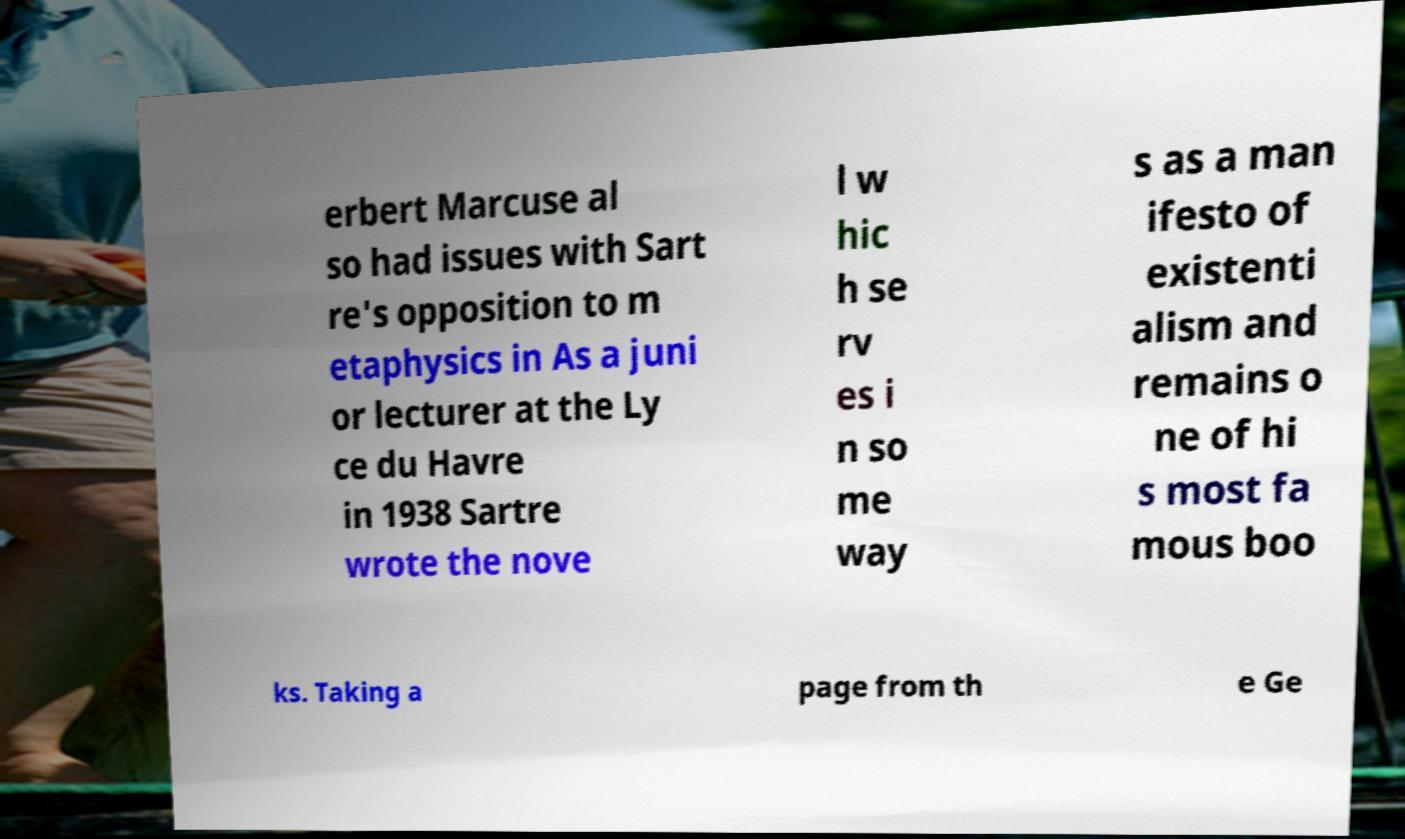For documentation purposes, I need the text within this image transcribed. Could you provide that? erbert Marcuse al so had issues with Sart re's opposition to m etaphysics in As a juni or lecturer at the Ly ce du Havre in 1938 Sartre wrote the nove l w hic h se rv es i n so me way s as a man ifesto of existenti alism and remains o ne of hi s most fa mous boo ks. Taking a page from th e Ge 